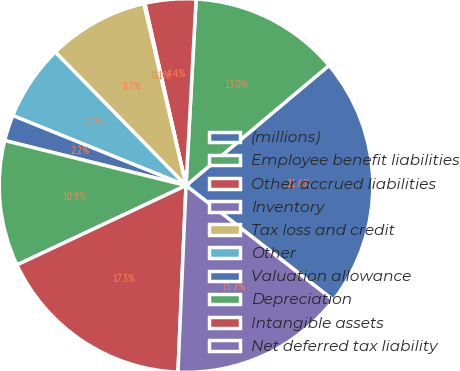Convert chart. <chart><loc_0><loc_0><loc_500><loc_500><pie_chart><fcel>(millions)<fcel>Employee benefit liabilities<fcel>Other accrued liabilities<fcel>Inventory<fcel>Tax loss and credit<fcel>Other<fcel>Valuation allowance<fcel>Depreciation<fcel>Intangible assets<fcel>Net deferred tax liability<nl><fcel>21.64%<fcel>13.02%<fcel>4.4%<fcel>0.09%<fcel>8.71%<fcel>6.55%<fcel>2.24%<fcel>10.86%<fcel>17.33%<fcel>15.17%<nl></chart> 